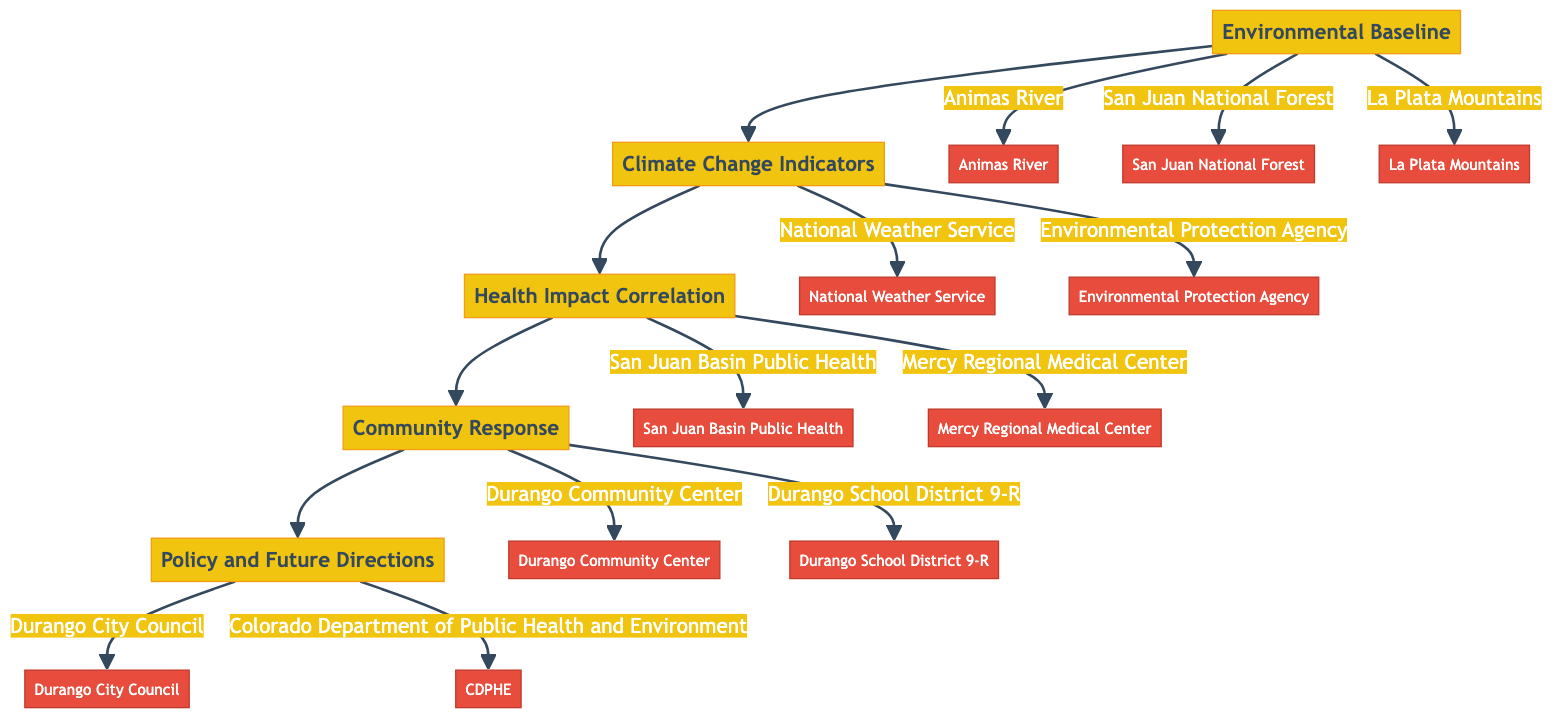What's the first stage in the pathway? The diagram indicates that the first stage is "Environmental Baseline," which initiates the flow of the clinical pathway.
Answer: Environmental Baseline How many key entities are associated with the "Health Impact Correlation" stage? The diagram shows two key entities connected to the "Health Impact Correlation" stage: "San Juan Basin Public Health" and "Mercy Regional Medical Center."
Answer: 2 What environmental feature is connected to the "Environmental Baseline" stage? The diagram connects three environmental features to this stage: "Animas River," "San Juan National Forest," and "La Plata Mountains."
Answer: Animas River Which stage follows "Community Response"? The diagram clearly shows that the "Policy and Future Directions" stage follows the "Community Response" stage in the flow of the clinical pathway.
Answer: Policy and Future Directions What is the focus of the "Climate Change Indicators" stage? The focus of the "Climate Change Indicators" stage is on identifying significant environmental changes, as detailed in the description provided in the diagram.
Answer: Identification of significant environmental changes How many stages are there in the entire pathway? The diagram presents five stages in total: Environmental Baseline, Climate Change Indicators, Health Impact Correlation, Community Response, and Policy and Future Directions.
Answer: 5 Which entity is linked to the "Community Response" stage? The diagram indicates that "Durango Community Center" and "Durango School District 9-R" are both linked to the "Community Response" stage as key entities.
Answer: Durango Community Center What are the long-term strategies mentioned in the last stage? The last stage includes strategies such as "Adoption of green energy solutions," "Urban planning for climate resilience," and "Long-term health monitoring initiatives."
Answer: Adoption of green energy solutions Which two entities are involved in the "Climate Change Indicators" stage? The entities specified in the diagram that are involved in the "Climate Change Indicators" stage are "National Weather Service" and "Environmental Protection Agency."
Answer: National Weather Service, Environmental Protection Agency 